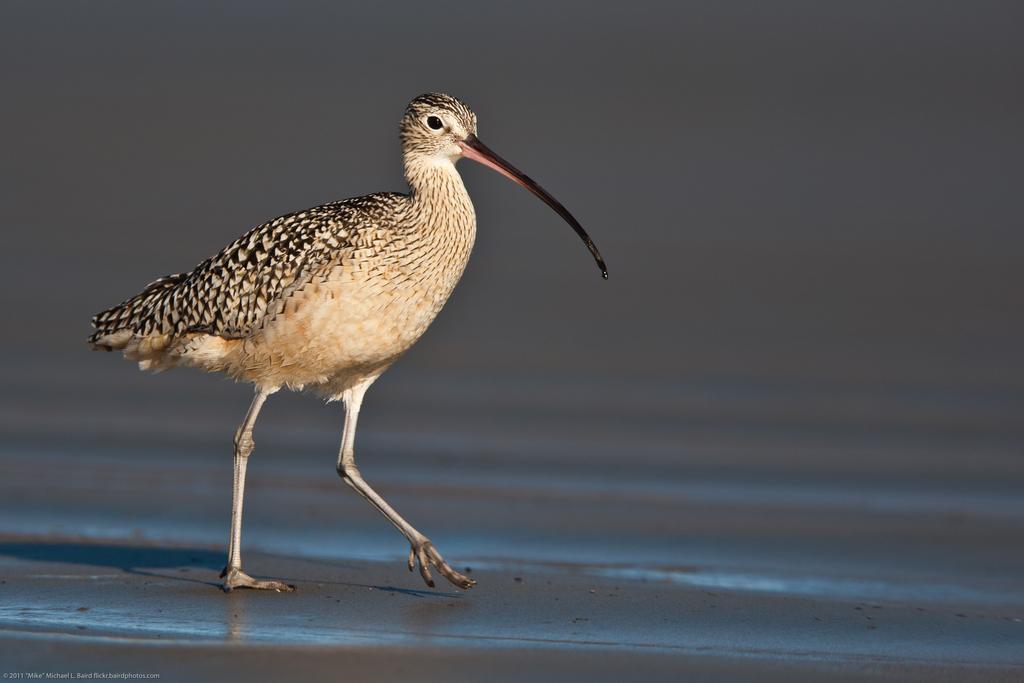Please provide a concise description of this image. In this image we can see a bird on the land. 